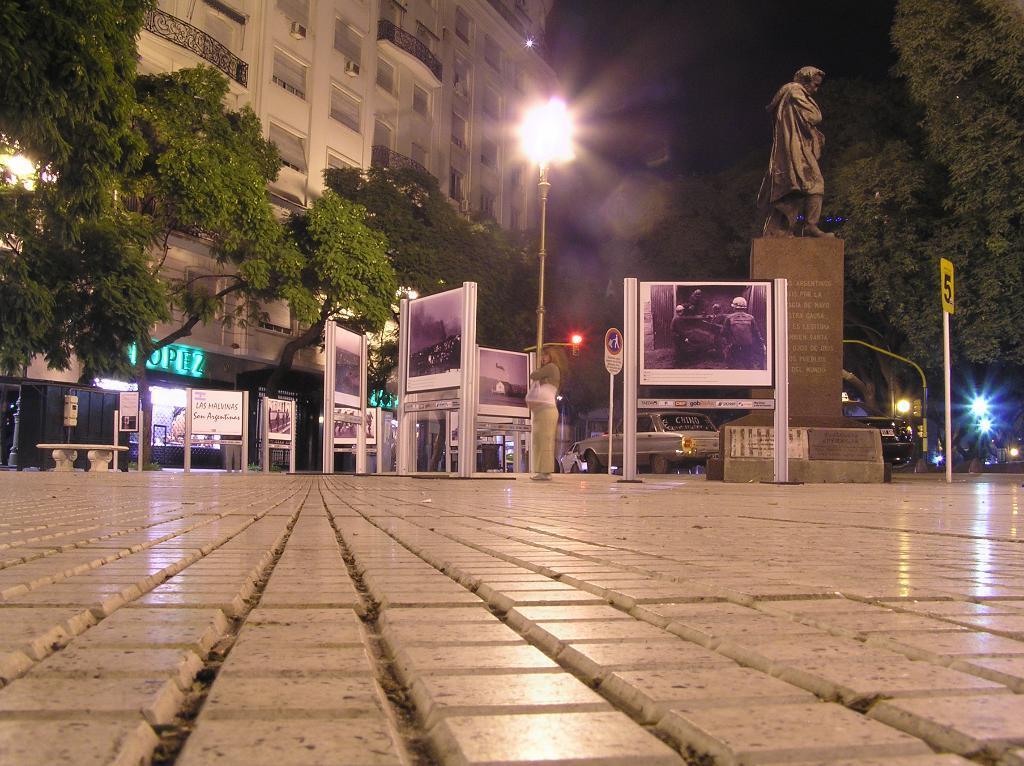In one or two sentences, can you explain what this image depicts? In this image we can see a woman is standing on the road. Behind her car, statue and banners are there. Background of the image trees and buildings are present. In the middle of the image light pole is there. 